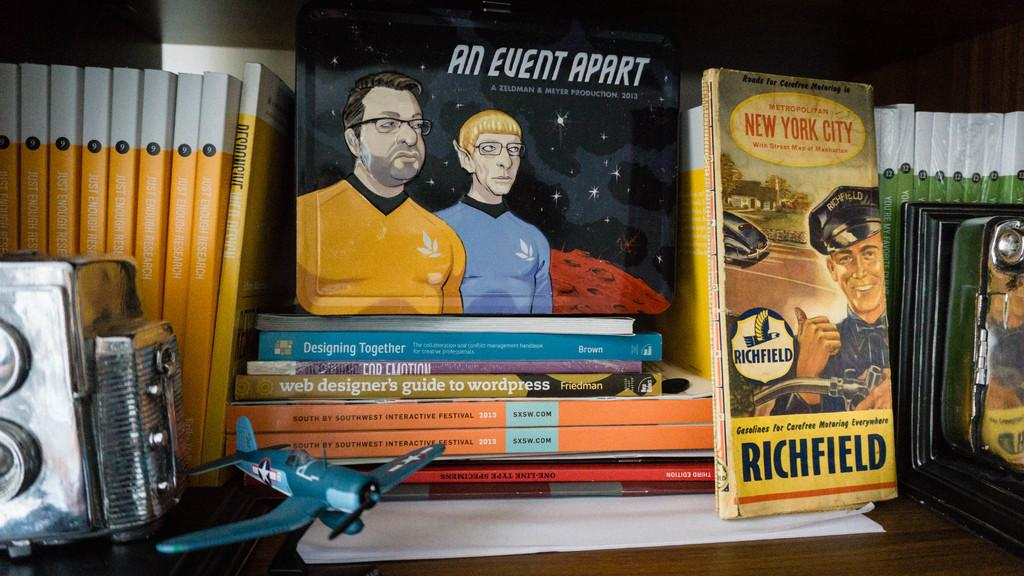What is the color of the wooden surface in the image? The wooden surface in the image is brown colored. What object related to flying can be seen on the wooden surface? There is a toy aircraft on the wooden surface. What device used for capturing images is present on the wooden surface? There is a camera on the wooden surface. What type of items are present for reading or learning? There are multiple books on the wooden surface. What colors are used in the background of the image? The background of the image is white and black colored. What type of vest is being worn by the camera in the image? There is no vest present in the image, as the camera is an inanimate object and does not wear clothing. 